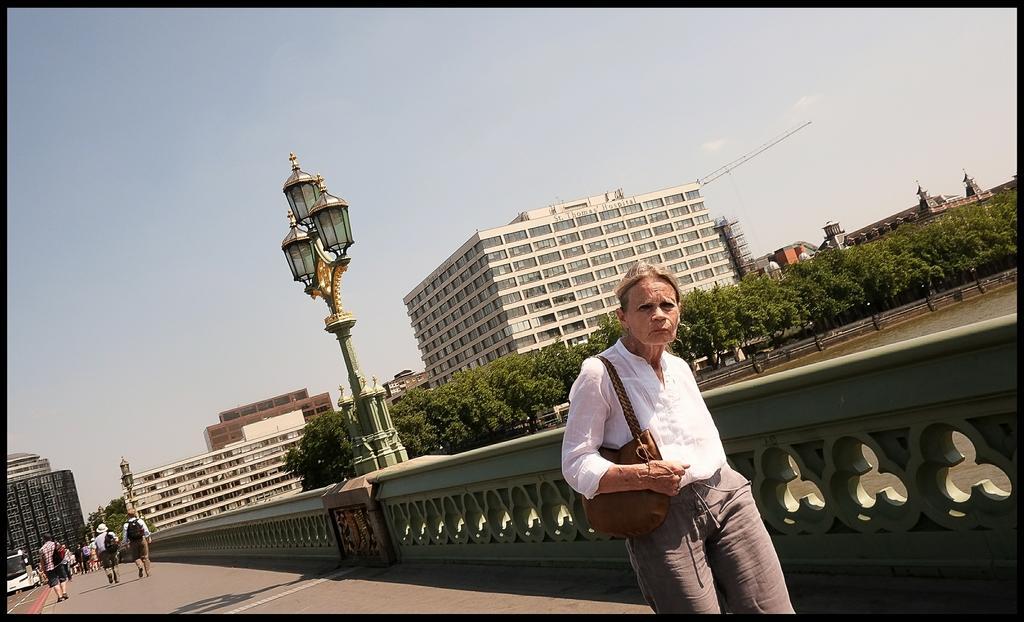Could you give a brief overview of what you see in this image? In this picture there is a woman carrying a bag and we can see railing, lights, poles, trees and water. In the background of the image people, vehicle on the road, buildings, crane and sky. 